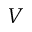<formula> <loc_0><loc_0><loc_500><loc_500>V</formula> 